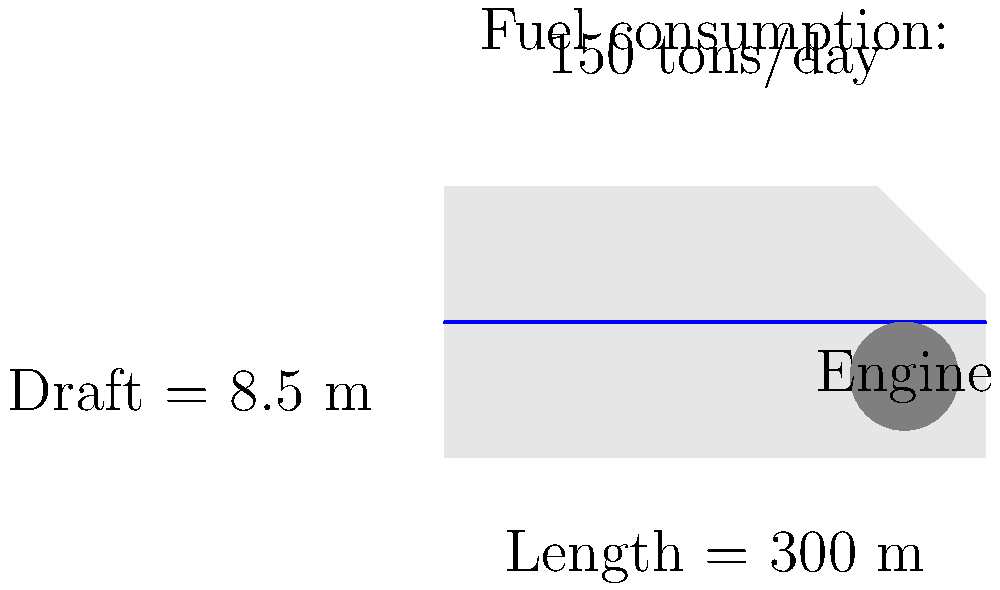A cruise ship has a length of 300 meters and a draft of 8.5 meters. Its engine consumes 150 tons of fuel per day. If the ship travels at a constant speed of 20 knots (nautical miles per hour), what is its fuel efficiency in terms of tons of fuel per nautical mile? To calculate the fuel efficiency, we need to determine the fuel consumption per nautical mile. Let's break it down step-by-step:

1. Convert the time frame to hours:
   1 day = 24 hours

2. Calculate the distance traveled in one day:
   Distance = Speed × Time
   $$ \text{Distance} = 20 \text{ knots} \times 24 \text{ hours} = 480 \text{ nautical miles} $$

3. We know the fuel consumption is 150 tons per day. Now, let's calculate the fuel efficiency:
   $$ \text{Fuel Efficiency} = \frac{\text{Fuel Consumed}}{\text{Distance Traveled}} $$
   $$ \text{Fuel Efficiency} = \frac{150 \text{ tons}}{480 \text{ nautical miles}} $$

4. Simplify the fraction:
   $$ \text{Fuel Efficiency} = \frac{5}{16} \text{ tons per nautical mile} $$

5. To express this as a decimal, divide 5 by 16:
   $$ \text{Fuel Efficiency} \approx 0.3125 \text{ tons per nautical mile} $$
Answer: 0.3125 tons/nautical mile 